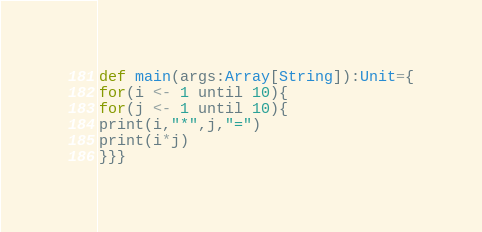<code> <loc_0><loc_0><loc_500><loc_500><_Scala_>def main(args:Array[String]):Unit={
for(i <- 1 until 10){
for(j <- 1 until 10){
print(i,"*",j,"=")
print(i*j)
}}}</code> 